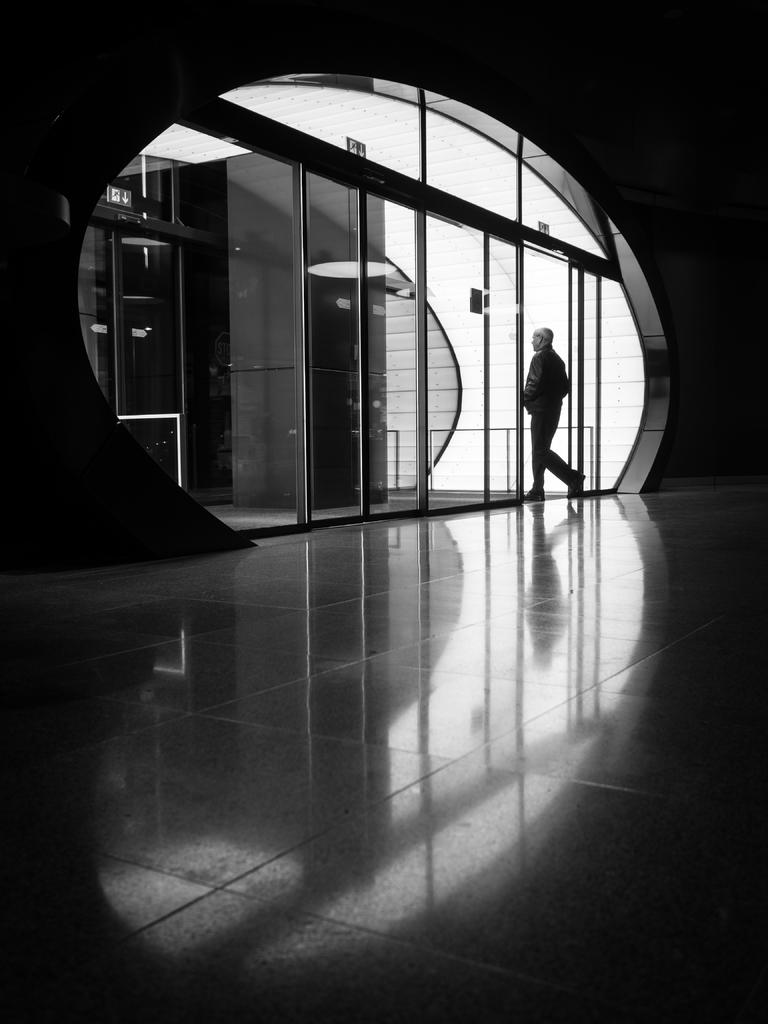What is the main subject in the image? There is a person standing on the floor in the image. What else can be seen in the image besides the person? There are doors visible in the image. Can you describe the lighting in the image? The image appears to be slightly dark. What type of plants can be seen growing on the farm in the image? There is no farm or plants present in the image; it features a person standing on the floor and doors. 